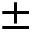<formula> <loc_0><loc_0><loc_500><loc_500>\pm</formula> 